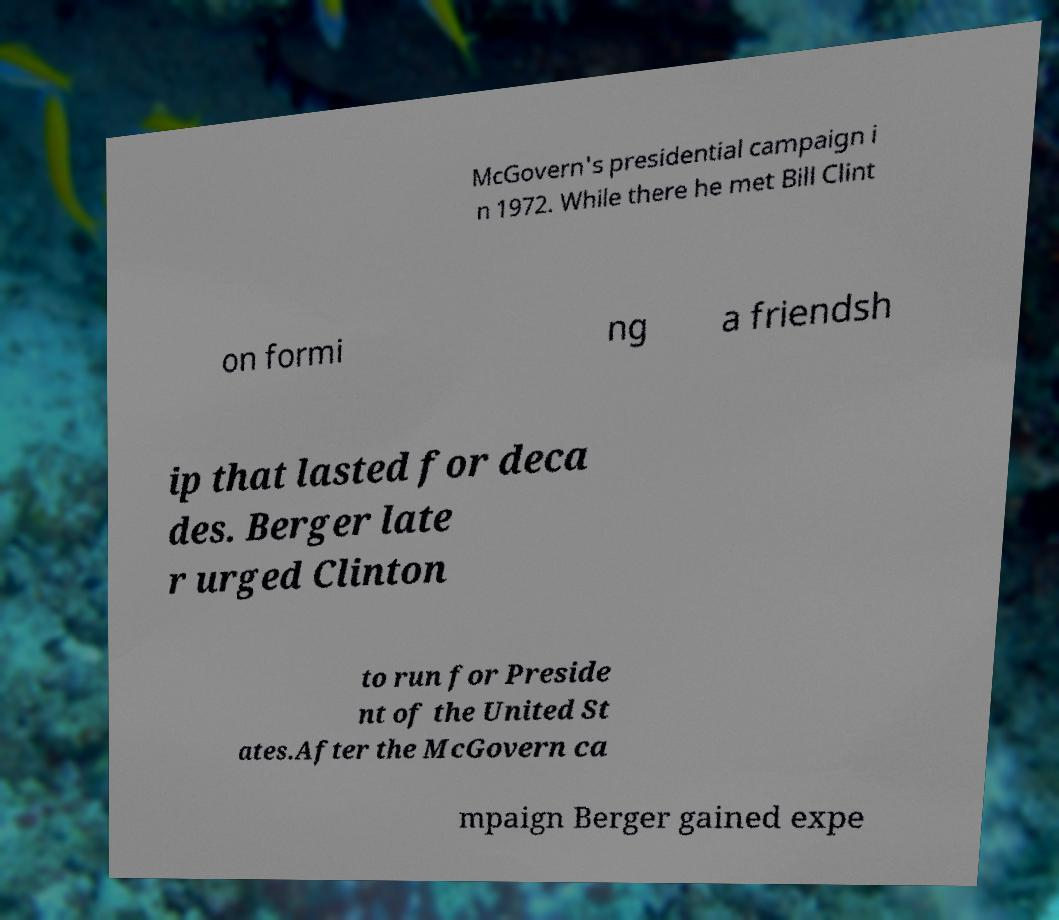There's text embedded in this image that I need extracted. Can you transcribe it verbatim? McGovern's presidential campaign i n 1972. While there he met Bill Clint on formi ng a friendsh ip that lasted for deca des. Berger late r urged Clinton to run for Preside nt of the United St ates.After the McGovern ca mpaign Berger gained expe 